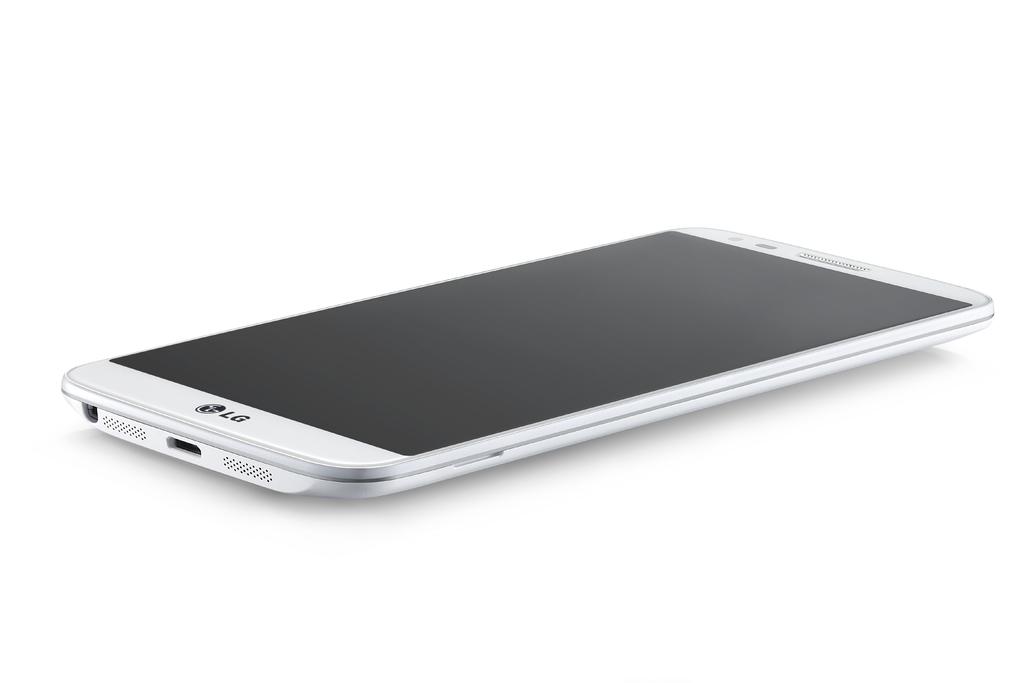What brand is this phone?
Offer a very short reply. Lg. 